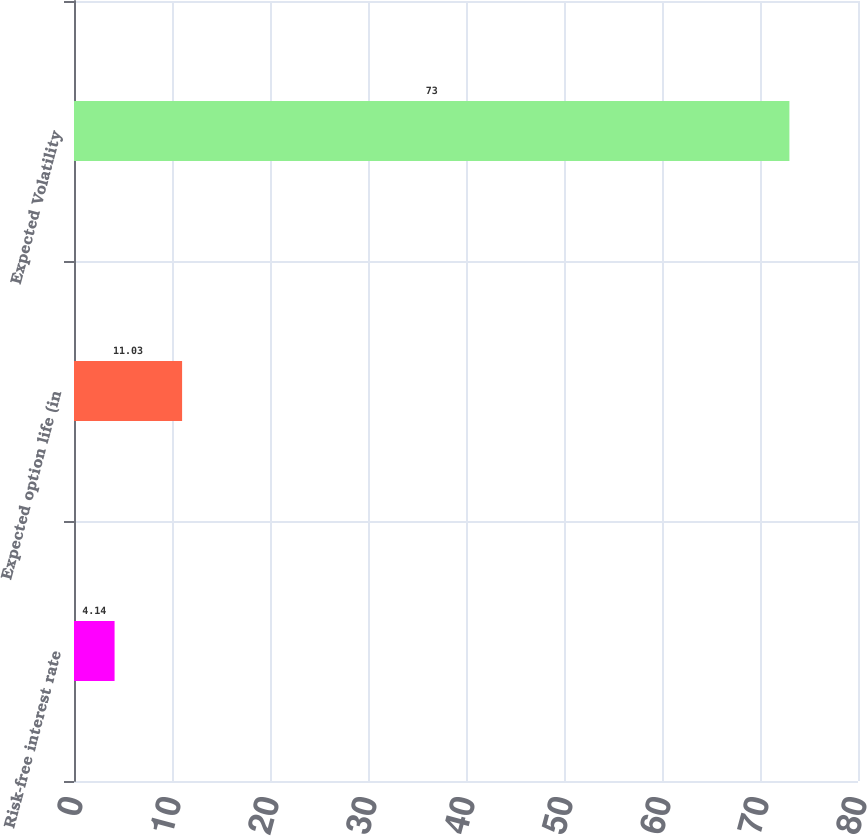Convert chart to OTSL. <chart><loc_0><loc_0><loc_500><loc_500><bar_chart><fcel>Risk-free interest rate<fcel>Expected option life (in<fcel>Expected Volatility<nl><fcel>4.14<fcel>11.03<fcel>73<nl></chart> 